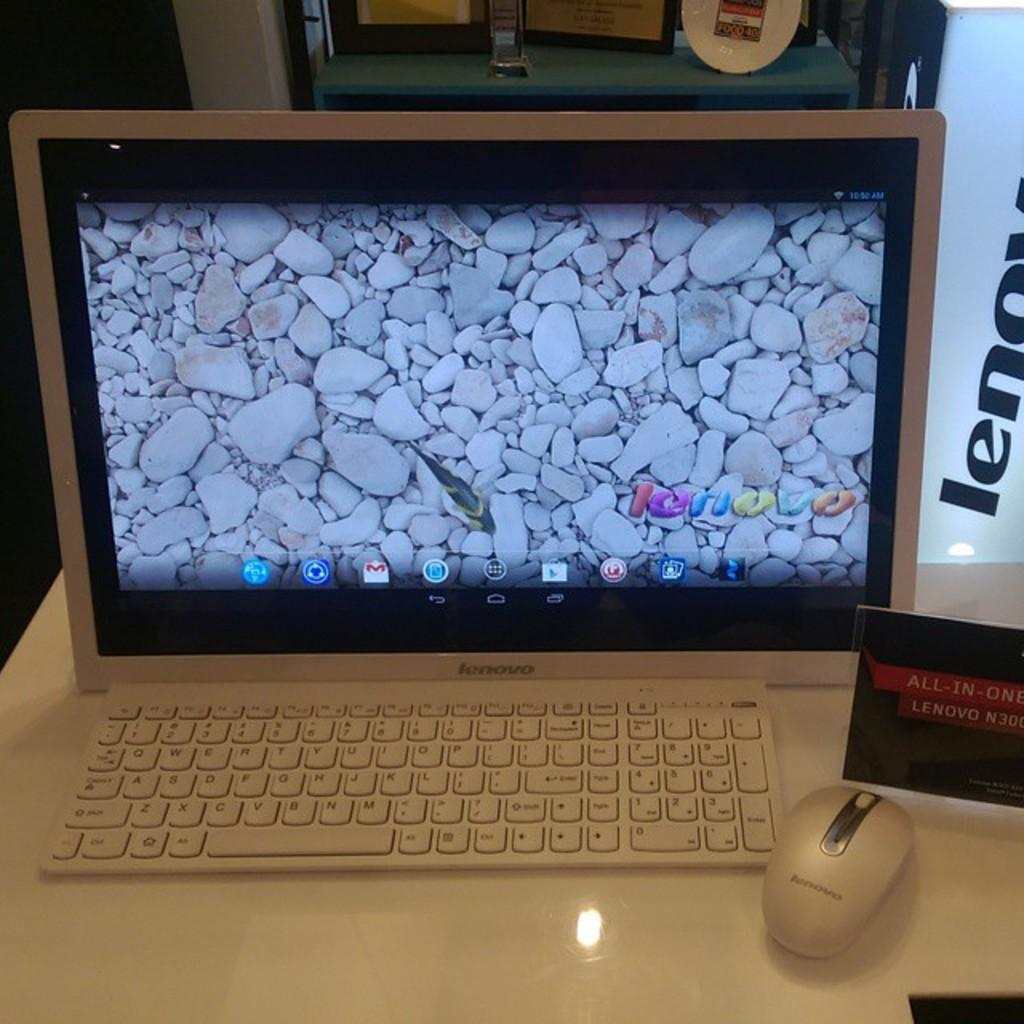<image>
Render a clear and concise summary of the photo. A screen with a white keyboard and mouse and all in one on a red and black sign. 